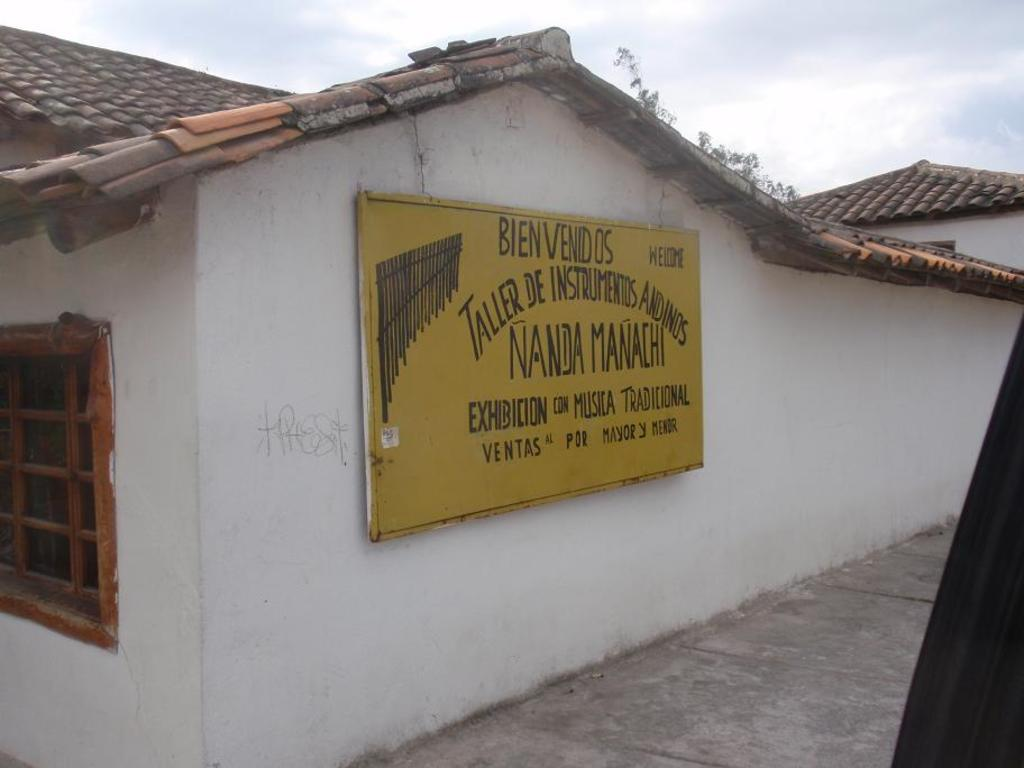<image>
Describe the image concisely. Yellow sign that starts with "Bien venidos" on a building wall. 